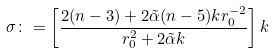Convert formula to latex. <formula><loc_0><loc_0><loc_500><loc_500>\sigma \colon = \left [ \frac { 2 ( n - 3 ) + 2 \tilde { \alpha } ( n - 5 ) k r _ { 0 } ^ { - 2 } } { r _ { 0 } ^ { 2 } + 2 \tilde { \alpha } k } \right ] k</formula> 